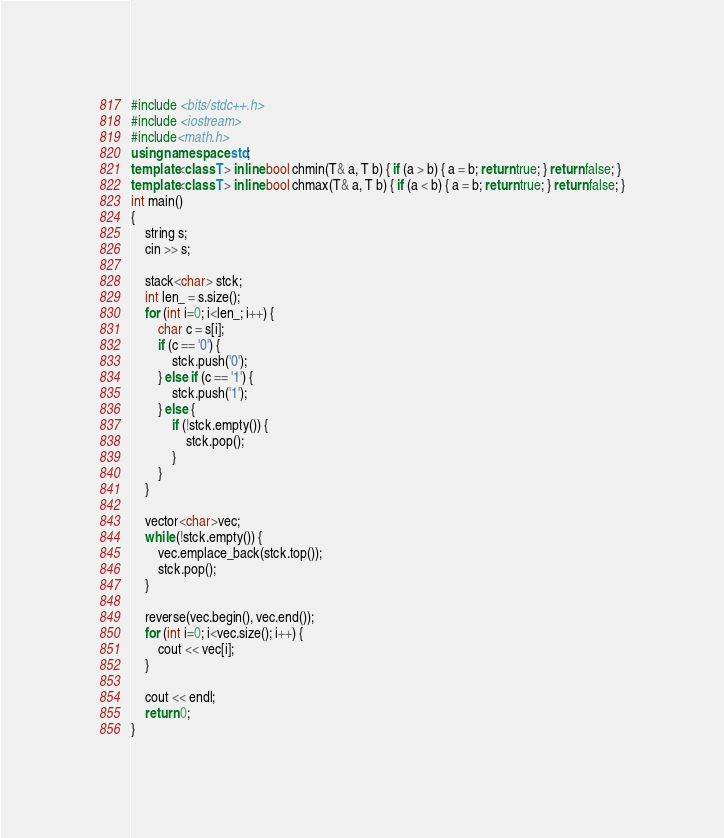Convert code to text. <code><loc_0><loc_0><loc_500><loc_500><_C++_>#include <bits/stdc++.h>
#include <iostream>
#include<math.h>
using namespace std;
template<class T> inline bool chmin(T& a, T b) { if (a > b) { a = b; return true; } return false; }
template<class T> inline bool chmax(T& a, T b) { if (a < b) { a = b; return true; } return false; }
int main()
{
    string s;
    cin >> s;

    stack<char> stck;
    int len_ = s.size();
    for (int i=0; i<len_; i++) {
        char c = s[i];
        if (c == '0') {
            stck.push('0');
        } else if (c == '1') {
            stck.push('1');
        } else {
            if (!stck.empty()) {
                stck.pop();
            }
        }
    }

    vector<char>vec;
    while (!stck.empty()) {
        vec.emplace_back(stck.top());
        stck.pop();
    }

    reverse(vec.begin(), vec.end());
    for (int i=0; i<vec.size(); i++) {
        cout << vec[i];
    }

    cout << endl;
    return 0;
}</code> 